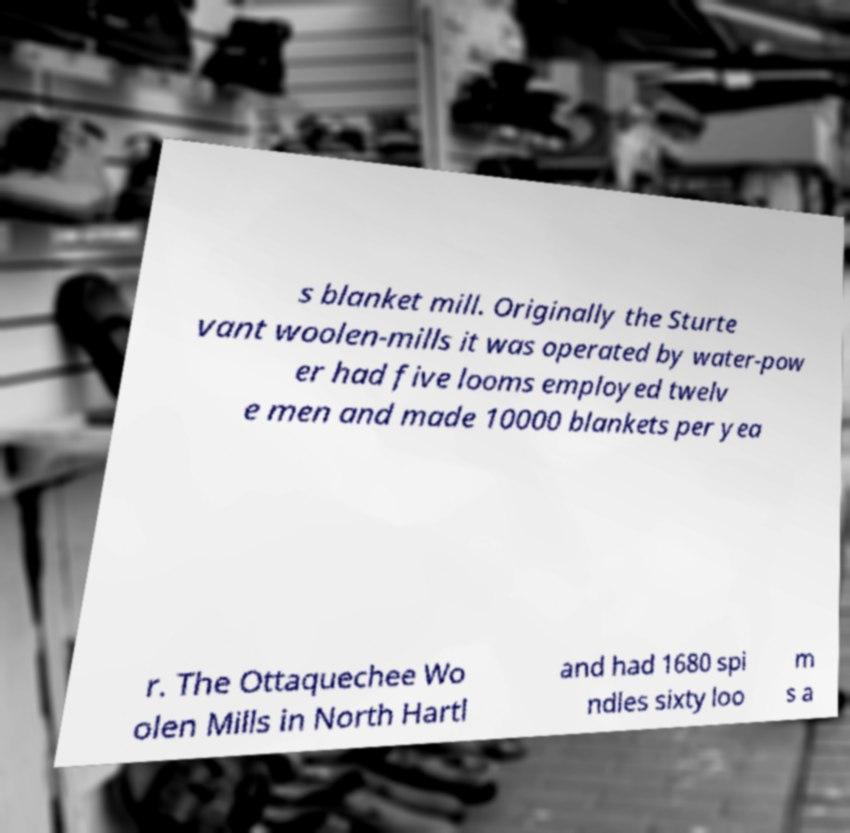Please read and relay the text visible in this image. What does it say? s blanket mill. Originally the Sturte vant woolen-mills it was operated by water-pow er had five looms employed twelv e men and made 10000 blankets per yea r. The Ottaquechee Wo olen Mills in North Hartl and had 1680 spi ndles sixty loo m s a 